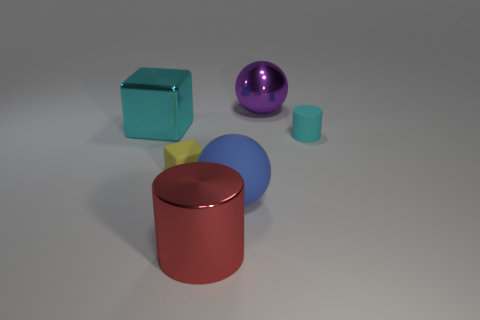Do the big ball behind the large metallic block and the big matte sphere have the same color?
Make the answer very short. No. Is there anything else that is the same color as the tiny matte cube?
Your answer should be compact. No. What color is the object that is to the right of the large purple metallic ball that is right of the metallic cylinder that is on the left side of the small cyan cylinder?
Your response must be concise. Cyan. Does the blue rubber thing have the same size as the cyan block?
Make the answer very short. Yes. What number of other blue matte balls are the same size as the blue matte ball?
Offer a terse response. 0. There is a tiny rubber thing that is the same color as the metal cube; what is its shape?
Keep it short and to the point. Cylinder. Does the ball in front of the large purple metallic sphere have the same material as the cylinder in front of the large blue matte thing?
Give a very brief answer. No. Is there anything else that is the same shape as the small cyan rubber object?
Keep it short and to the point. Yes. What is the color of the large metal cylinder?
Offer a terse response. Red. What number of large red metal objects are the same shape as the cyan rubber object?
Provide a succinct answer. 1. 